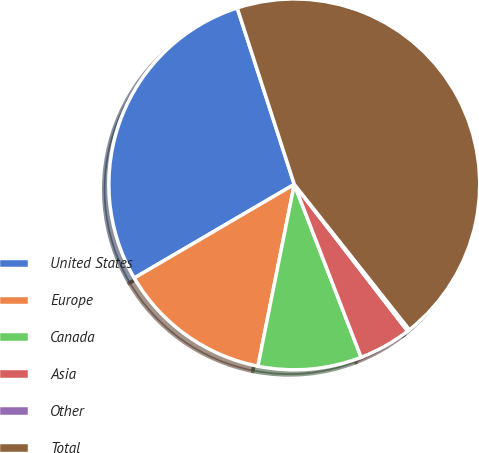Convert chart to OTSL. <chart><loc_0><loc_0><loc_500><loc_500><pie_chart><fcel>United States<fcel>Europe<fcel>Canada<fcel>Asia<fcel>Other<fcel>Total<nl><fcel>28.45%<fcel>13.43%<fcel>9.01%<fcel>4.6%<fcel>0.19%<fcel>44.32%<nl></chart> 